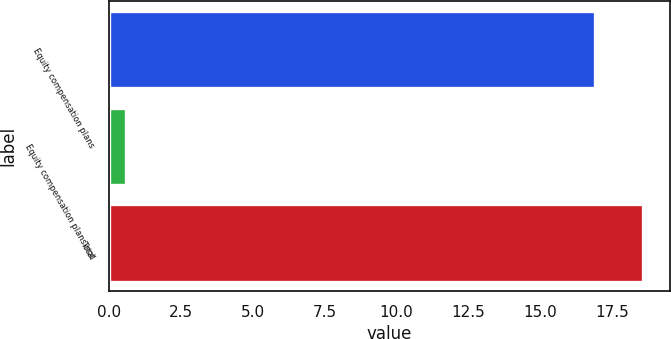Convert chart to OTSL. <chart><loc_0><loc_0><loc_500><loc_500><bar_chart><fcel>Equity compensation plans<fcel>Equity compensation plans not<fcel>Total<nl><fcel>16.9<fcel>0.6<fcel>18.59<nl></chart> 